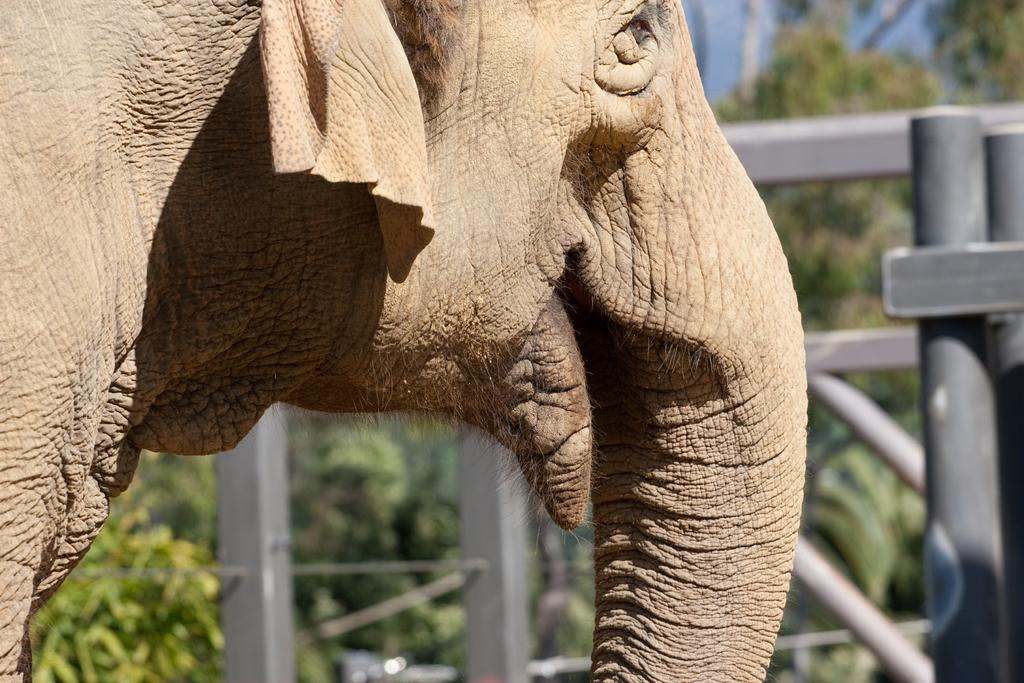What animal is present in the image? There is a gray color elephant in the image. What is the elephant's proximity to in the image? The elephant is near a gray color gate. What can be seen in the background of the image? There are trees in the background of the image. How many cups are on the elephant's back in the image? There are no cups present in the image; it features a gray color elephant near a gray color gate with trees in the background. 